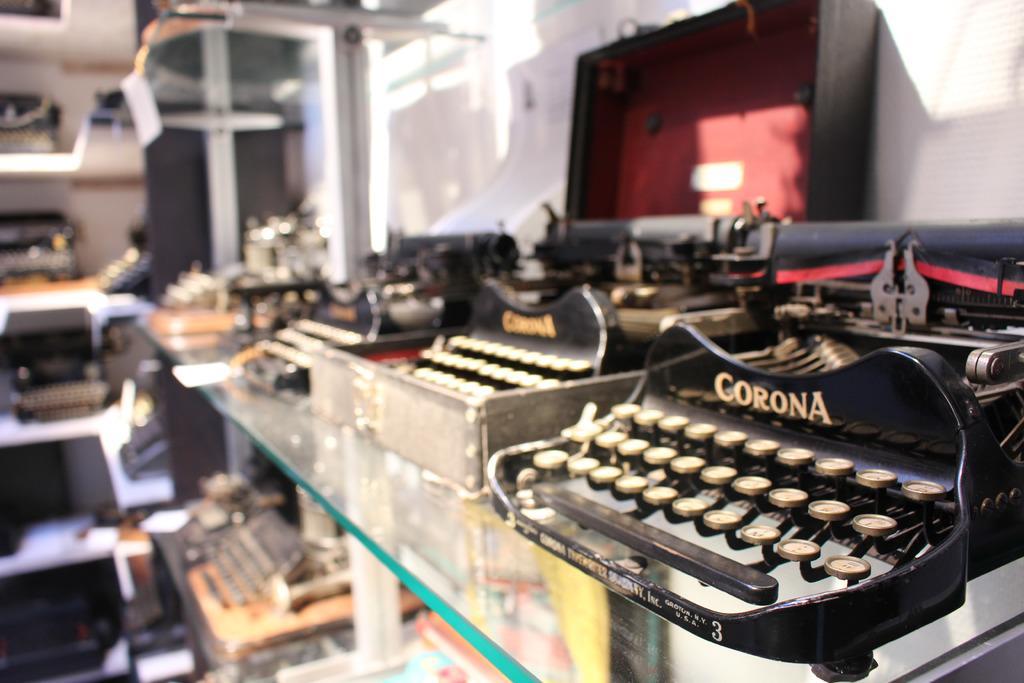In one or two sentences, can you explain what this image depicts? In this image there are a few typing machines on the shelves of a store. 